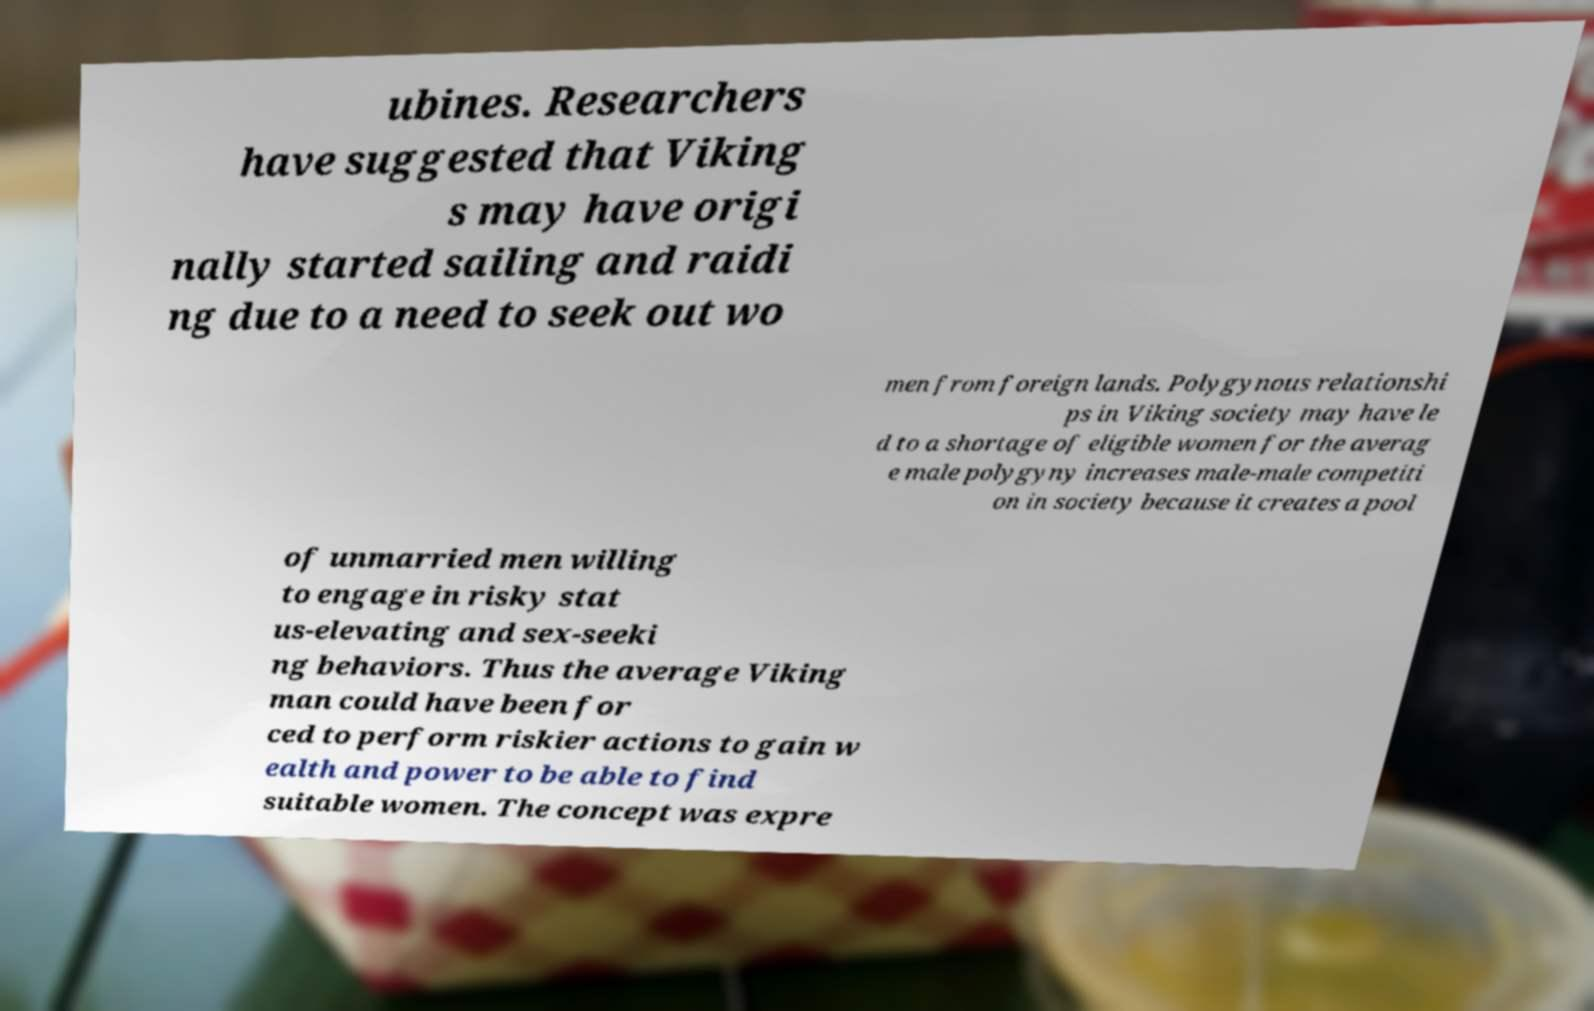I need the written content from this picture converted into text. Can you do that? ubines. Researchers have suggested that Viking s may have origi nally started sailing and raidi ng due to a need to seek out wo men from foreign lands. Polygynous relationshi ps in Viking society may have le d to a shortage of eligible women for the averag e male polygyny increases male-male competiti on in society because it creates a pool of unmarried men willing to engage in risky stat us-elevating and sex-seeki ng behaviors. Thus the average Viking man could have been for ced to perform riskier actions to gain w ealth and power to be able to find suitable women. The concept was expre 